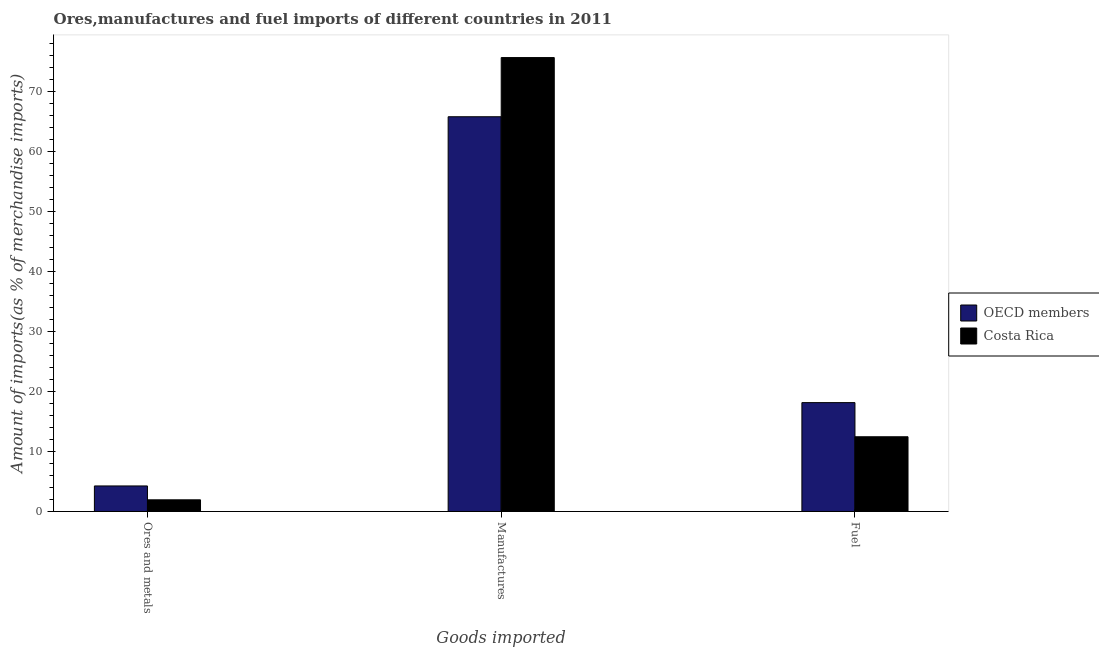How many different coloured bars are there?
Make the answer very short. 2. Are the number of bars per tick equal to the number of legend labels?
Ensure brevity in your answer.  Yes. How many bars are there on the 3rd tick from the left?
Provide a short and direct response. 2. What is the label of the 1st group of bars from the left?
Keep it short and to the point. Ores and metals. What is the percentage of fuel imports in OECD members?
Offer a terse response. 18.16. Across all countries, what is the maximum percentage of fuel imports?
Your answer should be compact. 18.16. Across all countries, what is the minimum percentage of ores and metals imports?
Your answer should be very brief. 1.95. What is the total percentage of fuel imports in the graph?
Provide a succinct answer. 30.63. What is the difference between the percentage of manufactures imports in OECD members and that in Costa Rica?
Make the answer very short. -9.87. What is the difference between the percentage of manufactures imports in OECD members and the percentage of fuel imports in Costa Rica?
Make the answer very short. 53.39. What is the average percentage of fuel imports per country?
Provide a succinct answer. 15.31. What is the difference between the percentage of manufactures imports and percentage of ores and metals imports in OECD members?
Provide a short and direct response. 61.59. In how many countries, is the percentage of fuel imports greater than 10 %?
Give a very brief answer. 2. What is the ratio of the percentage of ores and metals imports in OECD members to that in Costa Rica?
Offer a terse response. 2.19. Is the difference between the percentage of ores and metals imports in Costa Rica and OECD members greater than the difference between the percentage of manufactures imports in Costa Rica and OECD members?
Offer a terse response. No. What is the difference between the highest and the second highest percentage of ores and metals imports?
Ensure brevity in your answer.  2.31. What is the difference between the highest and the lowest percentage of ores and metals imports?
Offer a very short reply. 2.31. What does the 1st bar from the right in Manufactures represents?
Your response must be concise. Costa Rica. Is it the case that in every country, the sum of the percentage of ores and metals imports and percentage of manufactures imports is greater than the percentage of fuel imports?
Your answer should be very brief. Yes. How many bars are there?
Provide a succinct answer. 6. Are the values on the major ticks of Y-axis written in scientific E-notation?
Provide a short and direct response. No. How many legend labels are there?
Your answer should be very brief. 2. What is the title of the graph?
Provide a succinct answer. Ores,manufactures and fuel imports of different countries in 2011. Does "Algeria" appear as one of the legend labels in the graph?
Offer a terse response. No. What is the label or title of the X-axis?
Offer a terse response. Goods imported. What is the label or title of the Y-axis?
Provide a short and direct response. Amount of imports(as % of merchandise imports). What is the Amount of imports(as % of merchandise imports) of OECD members in Ores and metals?
Give a very brief answer. 4.26. What is the Amount of imports(as % of merchandise imports) of Costa Rica in Ores and metals?
Your answer should be very brief. 1.95. What is the Amount of imports(as % of merchandise imports) of OECD members in Manufactures?
Ensure brevity in your answer.  65.85. What is the Amount of imports(as % of merchandise imports) in Costa Rica in Manufactures?
Give a very brief answer. 75.73. What is the Amount of imports(as % of merchandise imports) of OECD members in Fuel?
Offer a very short reply. 18.16. What is the Amount of imports(as % of merchandise imports) of Costa Rica in Fuel?
Ensure brevity in your answer.  12.47. Across all Goods imported, what is the maximum Amount of imports(as % of merchandise imports) of OECD members?
Give a very brief answer. 65.85. Across all Goods imported, what is the maximum Amount of imports(as % of merchandise imports) of Costa Rica?
Make the answer very short. 75.73. Across all Goods imported, what is the minimum Amount of imports(as % of merchandise imports) of OECD members?
Provide a succinct answer. 4.26. Across all Goods imported, what is the minimum Amount of imports(as % of merchandise imports) in Costa Rica?
Provide a succinct answer. 1.95. What is the total Amount of imports(as % of merchandise imports) of OECD members in the graph?
Keep it short and to the point. 88.27. What is the total Amount of imports(as % of merchandise imports) of Costa Rica in the graph?
Your response must be concise. 90.14. What is the difference between the Amount of imports(as % of merchandise imports) of OECD members in Ores and metals and that in Manufactures?
Provide a short and direct response. -61.59. What is the difference between the Amount of imports(as % of merchandise imports) in Costa Rica in Ores and metals and that in Manufactures?
Make the answer very short. -73.78. What is the difference between the Amount of imports(as % of merchandise imports) in OECD members in Ores and metals and that in Fuel?
Give a very brief answer. -13.9. What is the difference between the Amount of imports(as % of merchandise imports) of Costa Rica in Ores and metals and that in Fuel?
Ensure brevity in your answer.  -10.52. What is the difference between the Amount of imports(as % of merchandise imports) in OECD members in Manufactures and that in Fuel?
Make the answer very short. 47.69. What is the difference between the Amount of imports(as % of merchandise imports) in Costa Rica in Manufactures and that in Fuel?
Make the answer very short. 63.26. What is the difference between the Amount of imports(as % of merchandise imports) in OECD members in Ores and metals and the Amount of imports(as % of merchandise imports) in Costa Rica in Manufactures?
Offer a terse response. -71.47. What is the difference between the Amount of imports(as % of merchandise imports) of OECD members in Ores and metals and the Amount of imports(as % of merchandise imports) of Costa Rica in Fuel?
Provide a short and direct response. -8.21. What is the difference between the Amount of imports(as % of merchandise imports) in OECD members in Manufactures and the Amount of imports(as % of merchandise imports) in Costa Rica in Fuel?
Your answer should be very brief. 53.39. What is the average Amount of imports(as % of merchandise imports) in OECD members per Goods imported?
Your answer should be compact. 29.42. What is the average Amount of imports(as % of merchandise imports) of Costa Rica per Goods imported?
Your answer should be very brief. 30.05. What is the difference between the Amount of imports(as % of merchandise imports) of OECD members and Amount of imports(as % of merchandise imports) of Costa Rica in Ores and metals?
Provide a succinct answer. 2.31. What is the difference between the Amount of imports(as % of merchandise imports) in OECD members and Amount of imports(as % of merchandise imports) in Costa Rica in Manufactures?
Your answer should be very brief. -9.87. What is the difference between the Amount of imports(as % of merchandise imports) in OECD members and Amount of imports(as % of merchandise imports) in Costa Rica in Fuel?
Your response must be concise. 5.7. What is the ratio of the Amount of imports(as % of merchandise imports) in OECD members in Ores and metals to that in Manufactures?
Offer a terse response. 0.06. What is the ratio of the Amount of imports(as % of merchandise imports) of Costa Rica in Ores and metals to that in Manufactures?
Your answer should be compact. 0.03. What is the ratio of the Amount of imports(as % of merchandise imports) in OECD members in Ores and metals to that in Fuel?
Ensure brevity in your answer.  0.23. What is the ratio of the Amount of imports(as % of merchandise imports) of Costa Rica in Ores and metals to that in Fuel?
Provide a succinct answer. 0.16. What is the ratio of the Amount of imports(as % of merchandise imports) in OECD members in Manufactures to that in Fuel?
Keep it short and to the point. 3.63. What is the ratio of the Amount of imports(as % of merchandise imports) of Costa Rica in Manufactures to that in Fuel?
Provide a succinct answer. 6.07. What is the difference between the highest and the second highest Amount of imports(as % of merchandise imports) in OECD members?
Ensure brevity in your answer.  47.69. What is the difference between the highest and the second highest Amount of imports(as % of merchandise imports) of Costa Rica?
Make the answer very short. 63.26. What is the difference between the highest and the lowest Amount of imports(as % of merchandise imports) of OECD members?
Make the answer very short. 61.59. What is the difference between the highest and the lowest Amount of imports(as % of merchandise imports) of Costa Rica?
Provide a succinct answer. 73.78. 